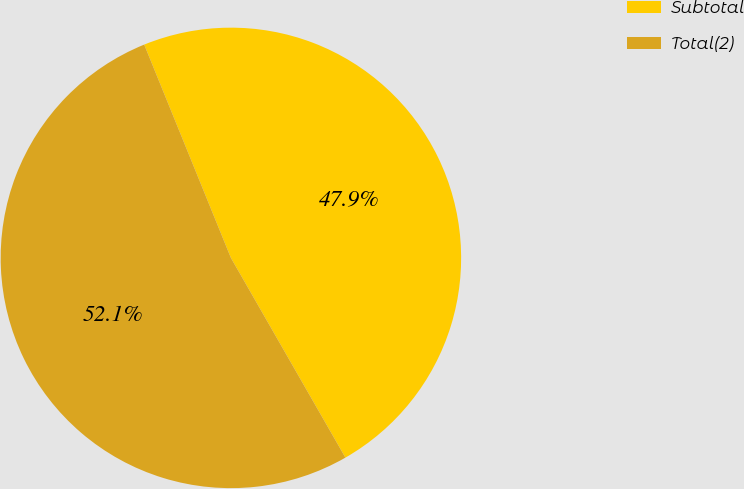Convert chart. <chart><loc_0><loc_0><loc_500><loc_500><pie_chart><fcel>Subtotal<fcel>Total(2)<nl><fcel>47.86%<fcel>52.14%<nl></chart> 